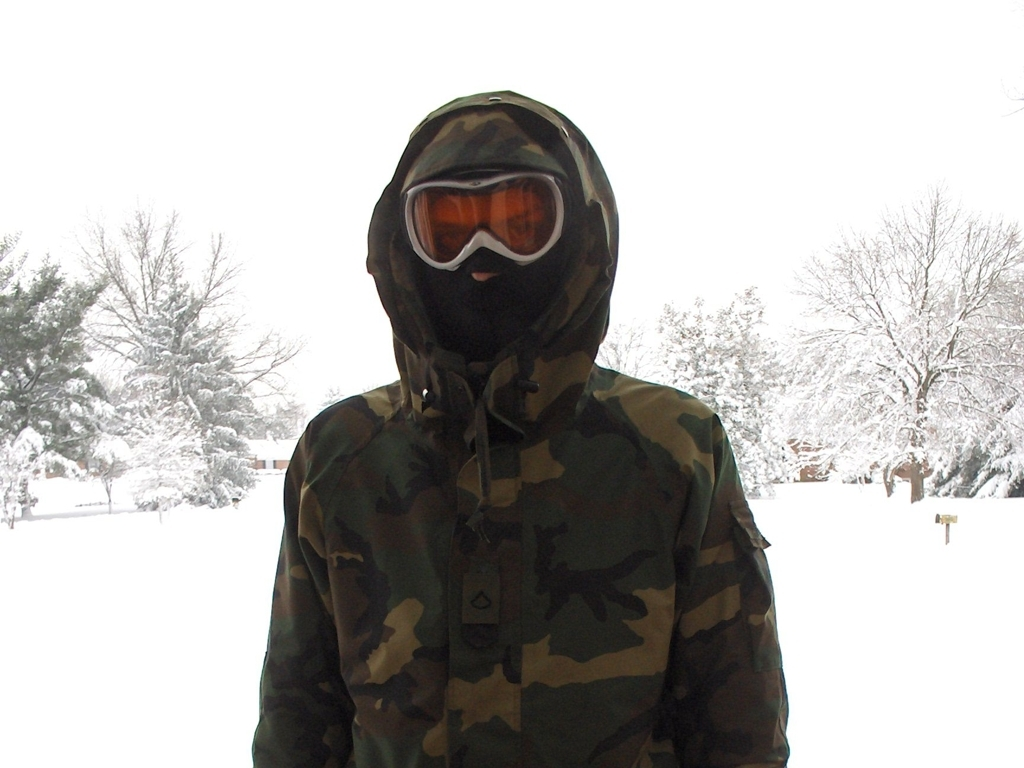Is there significant noise in the image?
 No 